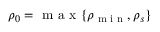Convert formula to latex. <formula><loc_0><loc_0><loc_500><loc_500>\rho _ { 0 } = \max \{ \rho _ { \min } , \rho _ { s } \}</formula> 